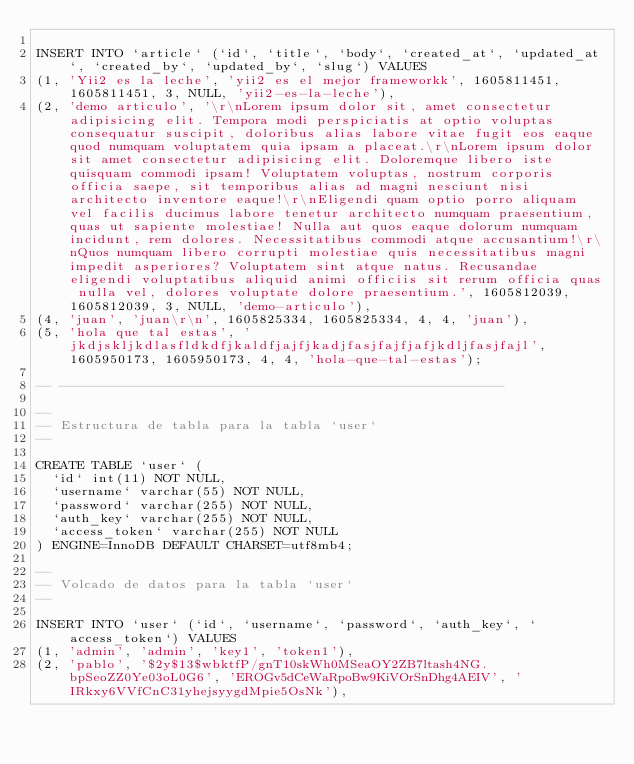<code> <loc_0><loc_0><loc_500><loc_500><_SQL_>
INSERT INTO `article` (`id`, `title`, `body`, `created_at`, `updated_at`, `created_by`, `updated_by`, `slug`) VALUES
(1, 'Yii2 es la leche', 'yii2 es el mejor frameworkk', 1605811451, 1605811451, 3, NULL, 'yii2-es-la-leche'),
(2, 'demo articulo', '\r\nLorem ipsum dolor sit, amet consectetur adipisicing elit. Tempora modi perspiciatis at optio voluptas consequatur suscipit, doloribus alias labore vitae fugit eos eaque quod numquam voluptatem quia ipsam a placeat.\r\nLorem ipsum dolor sit amet consectetur adipisicing elit. Doloremque libero iste quisquam commodi ipsam! Voluptatem voluptas, nostrum corporis officia saepe, sit temporibus alias ad magni nesciunt nisi architecto inventore eaque!\r\nEligendi quam optio porro aliquam vel facilis ducimus labore tenetur architecto numquam praesentium, quas ut sapiente molestiae! Nulla aut quos eaque dolorum numquam incidunt, rem dolores. Necessitatibus commodi atque accusantium!\r\nQuos numquam libero corrupti molestiae quis necessitatibus magni impedit asperiores? Voluptatem sint atque natus. Recusandae eligendi voluptatibus aliquid animi officiis sit rerum officia quas nulla vel, dolores voluptate dolore praesentium.', 1605812039, 1605812039, 3, NULL, 'demo-articulo'),
(4, 'juan', 'juan\r\n', 1605825334, 1605825334, 4, 4, 'juan'),
(5, 'hola que tal estas', 'jkdjskljkdlasfldkdfjkaldfjajfjkadjfasjfajfjafjkdljfasjfajl', 1605950173, 1605950173, 4, 4, 'hola-que-tal-estas');

-- --------------------------------------------------------

--
-- Estructura de tabla para la tabla `user`
--

CREATE TABLE `user` (
  `id` int(11) NOT NULL,
  `username` varchar(55) NOT NULL,
  `password` varchar(255) NOT NULL,
  `auth_key` varchar(255) NOT NULL,
  `access_token` varchar(255) NOT NULL
) ENGINE=InnoDB DEFAULT CHARSET=utf8mb4;

--
-- Volcado de datos para la tabla `user`
--

INSERT INTO `user` (`id`, `username`, `password`, `auth_key`, `access_token`) VALUES
(1, 'admin', 'admin', 'key1', 'token1'),
(2, 'pablo', '$2y$13$wbktfP/gnT10skWh0MSeaOY2ZB7ltash4NG.bpSeoZZ0Ye03oL0G6', 'EROGv5dCeWaRpoBw9KiVOrSnDhg4AEIV', 'IRkxy6VVfCnC31yhejsyygdMpie5OsNk'),</code> 